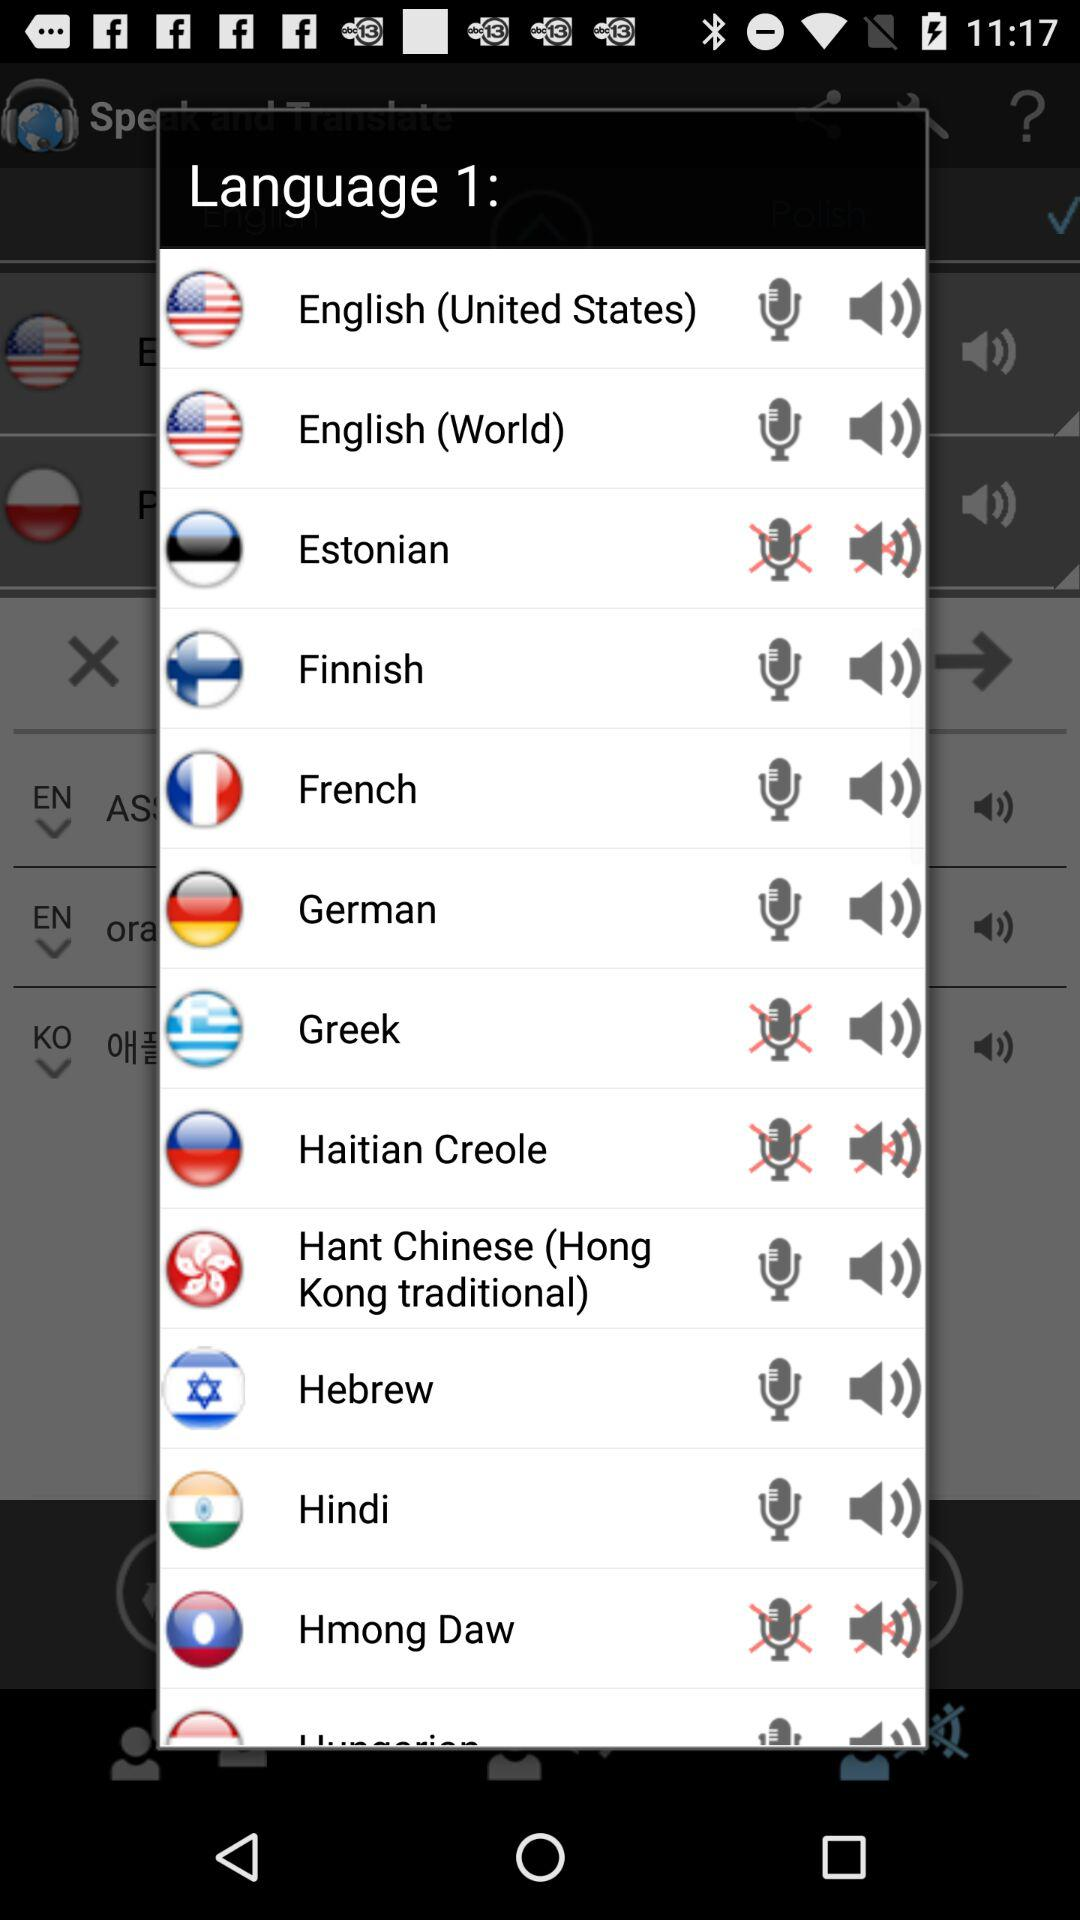What are the enlisted languages that come under " Language 1"? The enlisted languages are "English (United States)", "English (World)", "Estonian", "Finnish", "French", "German", "Greek", "Haitian Creole", "Hant Chinese (Hong Kong traditional)", "Hebrew", "Hindi" and "Hmong Daw". 